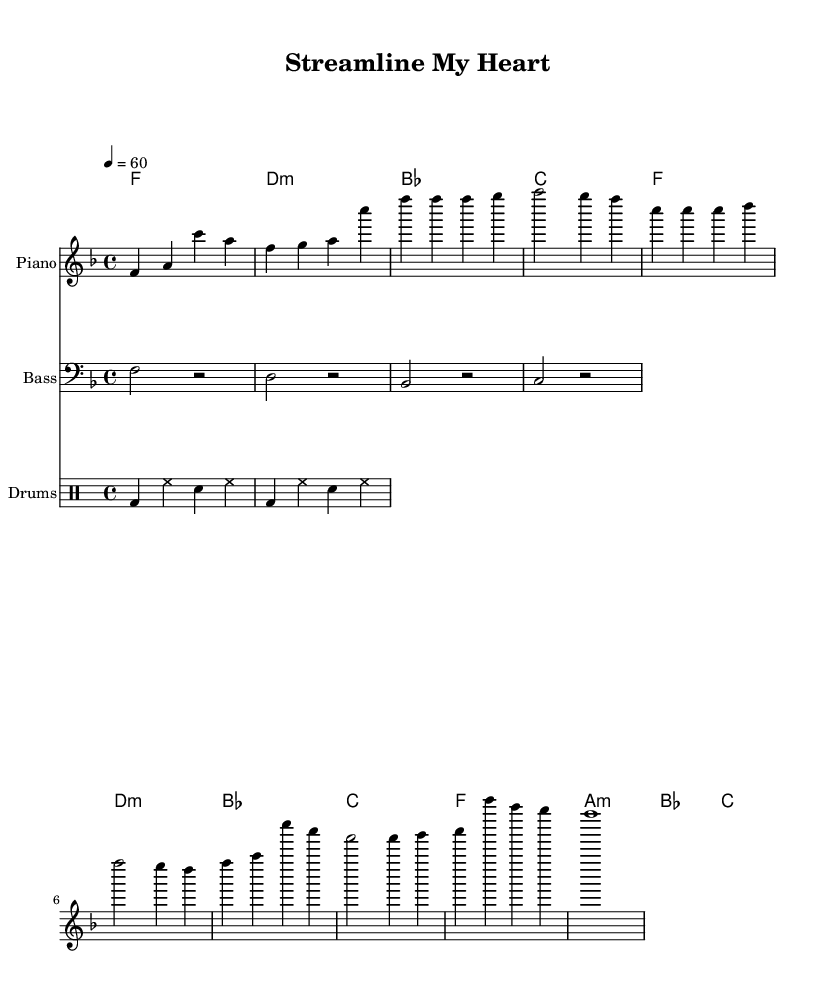What is the key signature of this music? The key signature shown is F major, which has one flat (B flat). This can be determined by looking at the key signature indicated at the beginning of the music.
Answer: F major What is the time signature of this music? The time signature is 4/4, which is evident in the beginning of the score. This means there are four beats in each measure.
Answer: 4/4 What is the tempo marking for this piece? The tempo marking indicates a speed of 60 beats per minute, shown by "4 = 60". This indicates the metronome marking for the piece.
Answer: 60 How many measures are in the chorus section? The chorus consists of four measures, identifiable by looking at the measures labeled in the sheet music where the chorus occurs.
Answer: 4 What type of rhythm does this music primarily use? The rhythm used throughout the piece is primarily a swing feel, which can be inferred from the 4/4 time signature combined with the laid-back feel typical for Rhythm and Blues music.
Answer: Swing What is the primary theme of the lyrics? The lyrics focus on digital platforms and efficiency in the housing application process, discussing how they simplify procedures. This can be deduced from the text printed under the melody line.
Answer: Digital platforms What is the instrument used for the melody? The melody is played on the piano, which is indicated by the instrument name specified at the beginning of the staff designated for the melody.
Answer: Piano 